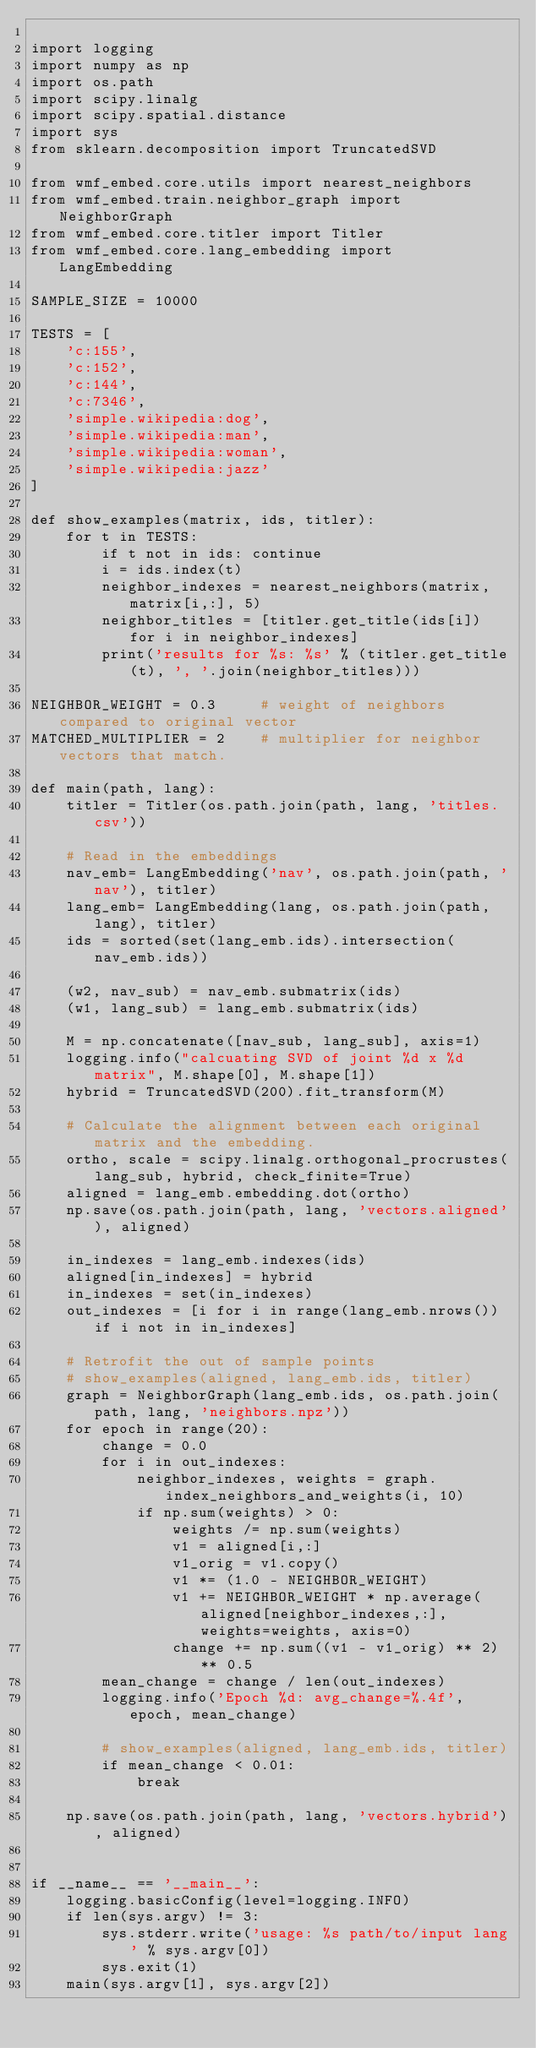<code> <loc_0><loc_0><loc_500><loc_500><_Python_>
import logging
import numpy as np
import os.path
import scipy.linalg
import scipy.spatial.distance
import sys
from sklearn.decomposition import TruncatedSVD

from wmf_embed.core.utils import nearest_neighbors
from wmf_embed.train.neighbor_graph import NeighborGraph
from wmf_embed.core.titler import Titler
from wmf_embed.core.lang_embedding import LangEmbedding

SAMPLE_SIZE = 10000

TESTS = [
    'c:155',
    'c:152',
    'c:144',
    'c:7346',
    'simple.wikipedia:dog',
    'simple.wikipedia:man',
    'simple.wikipedia:woman',
    'simple.wikipedia:jazz'
]

def show_examples(matrix, ids, titler):
    for t in TESTS:
        if t not in ids: continue
        i = ids.index(t)
        neighbor_indexes = nearest_neighbors(matrix, matrix[i,:], 5)
        neighbor_titles = [titler.get_title(ids[i]) for i in neighbor_indexes]
        print('results for %s: %s' % (titler.get_title(t), ', '.join(neighbor_titles)))

NEIGHBOR_WEIGHT = 0.3     # weight of neighbors compared to original vector
MATCHED_MULTIPLIER = 2    # multiplier for neighbor vectors that match.

def main(path, lang):
    titler = Titler(os.path.join(path, lang, 'titles.csv'))

    # Read in the embeddings
    nav_emb= LangEmbedding('nav', os.path.join(path, 'nav'), titler)
    lang_emb= LangEmbedding(lang, os.path.join(path, lang), titler)
    ids = sorted(set(lang_emb.ids).intersection(nav_emb.ids))

    (w2, nav_sub) = nav_emb.submatrix(ids)
    (w1, lang_sub) = lang_emb.submatrix(ids)

    M = np.concatenate([nav_sub, lang_sub], axis=1)
    logging.info("calcuating SVD of joint %d x %d matrix", M.shape[0], M.shape[1])
    hybrid = TruncatedSVD(200).fit_transform(M)

    # Calculate the alignment between each original matrix and the embedding.
    ortho, scale = scipy.linalg.orthogonal_procrustes(lang_sub, hybrid, check_finite=True)
    aligned = lang_emb.embedding.dot(ortho)
    np.save(os.path.join(path, lang, 'vectors.aligned'), aligned)

    in_indexes = lang_emb.indexes(ids)
    aligned[in_indexes] = hybrid
    in_indexes = set(in_indexes)
    out_indexes = [i for i in range(lang_emb.nrows()) if i not in in_indexes]

    # Retrofit the out of sample points
    # show_examples(aligned, lang_emb.ids, titler)
    graph = NeighborGraph(lang_emb.ids, os.path.join(path, lang, 'neighbors.npz'))
    for epoch in range(20):
        change = 0.0
        for i in out_indexes:
            neighbor_indexes, weights = graph.index_neighbors_and_weights(i, 10)
            if np.sum(weights) > 0:
                weights /= np.sum(weights)
                v1 = aligned[i,:]
                v1_orig = v1.copy()
                v1 *= (1.0 - NEIGHBOR_WEIGHT)
                v1 += NEIGHBOR_WEIGHT * np.average(aligned[neighbor_indexes,:], weights=weights, axis=0)
                change += np.sum((v1 - v1_orig) ** 2) ** 0.5
        mean_change = change / len(out_indexes)
        logging.info('Epoch %d: avg_change=%.4f', epoch, mean_change)

        # show_examples(aligned, lang_emb.ids, titler)
        if mean_change < 0.01:
            break

    np.save(os.path.join(path, lang, 'vectors.hybrid'), aligned)


if __name__ == '__main__':
    logging.basicConfig(level=logging.INFO)
    if len(sys.argv) != 3:
        sys.stderr.write('usage: %s path/to/input lang' % sys.argv[0])
        sys.exit(1)
    main(sys.argv[1], sys.argv[2])</code> 